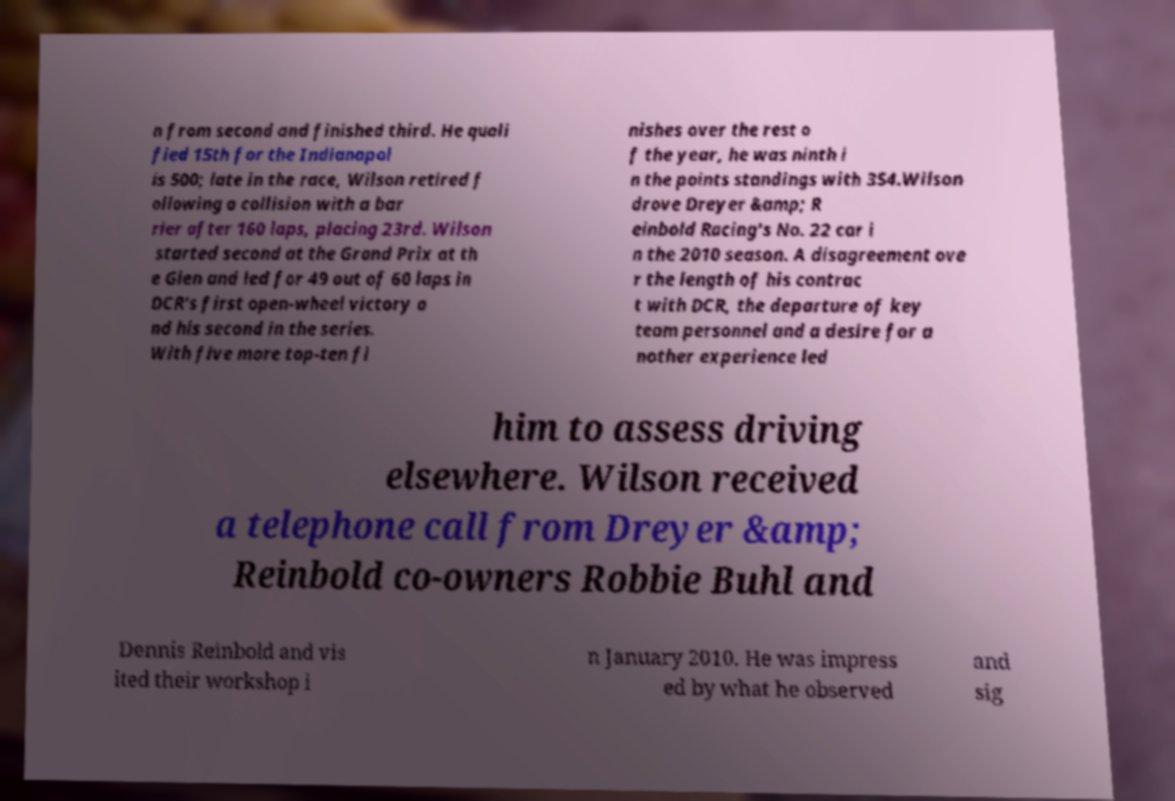Can you accurately transcribe the text from the provided image for me? n from second and finished third. He quali fied 15th for the Indianapol is 500; late in the race, Wilson retired f ollowing a collision with a bar rier after 160 laps, placing 23rd. Wilson started second at the Grand Prix at th e Glen and led for 49 out of 60 laps in DCR's first open-wheel victory a nd his second in the series. With five more top-ten fi nishes over the rest o f the year, he was ninth i n the points standings with 354.Wilson drove Dreyer &amp; R einbold Racing's No. 22 car i n the 2010 season. A disagreement ove r the length of his contrac t with DCR, the departure of key team personnel and a desire for a nother experience led him to assess driving elsewhere. Wilson received a telephone call from Dreyer &amp; Reinbold co-owners Robbie Buhl and Dennis Reinbold and vis ited their workshop i n January 2010. He was impress ed by what he observed and sig 